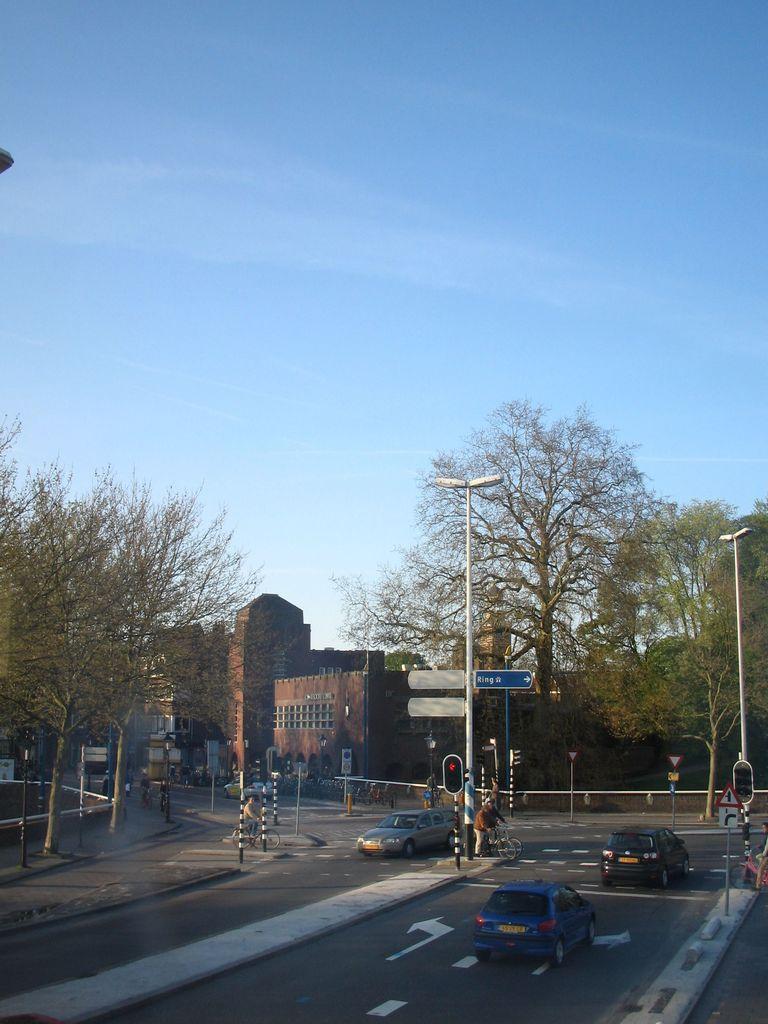Can you describe this image briefly? In this image, there are trees, buildings, street lights, sign boards, traffic lights and poles. At the bottom of the image, I can see fence, few people riding bicycles and there are vehicles on the road. In the background, there is the sky. 